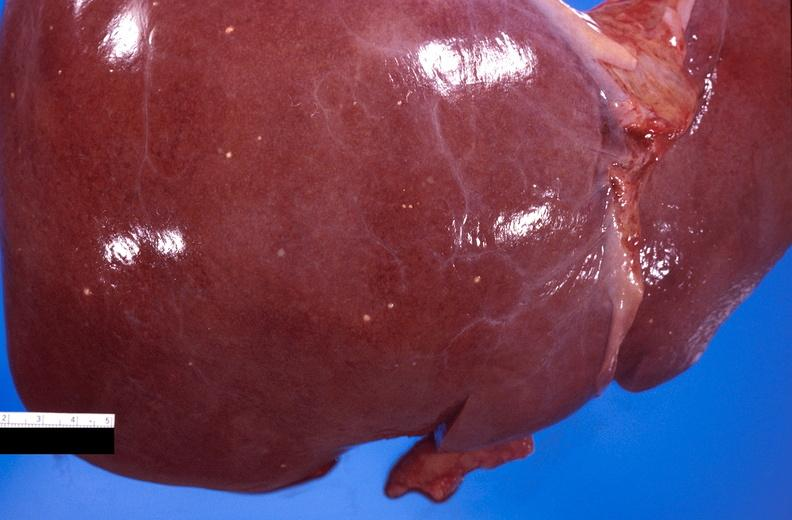does this image show liver, fungal abscesses, candida?
Answer the question using a single word or phrase. Yes 